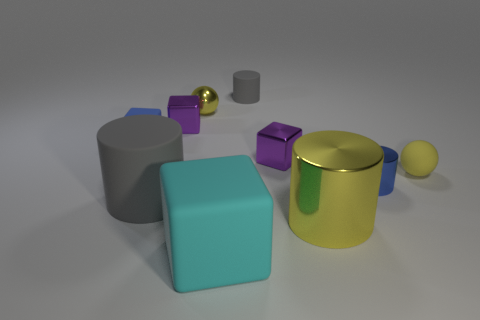Subtract 1 blocks. How many blocks are left? 3 Subtract all brown blocks. Subtract all blue cylinders. How many blocks are left? 4 Subtract all cylinders. How many objects are left? 6 Add 2 tiny purple blocks. How many tiny purple blocks exist? 4 Subtract 0 purple cylinders. How many objects are left? 10 Subtract all big yellow rubber cubes. Subtract all purple shiny blocks. How many objects are left? 8 Add 5 small blue blocks. How many small blue blocks are left? 6 